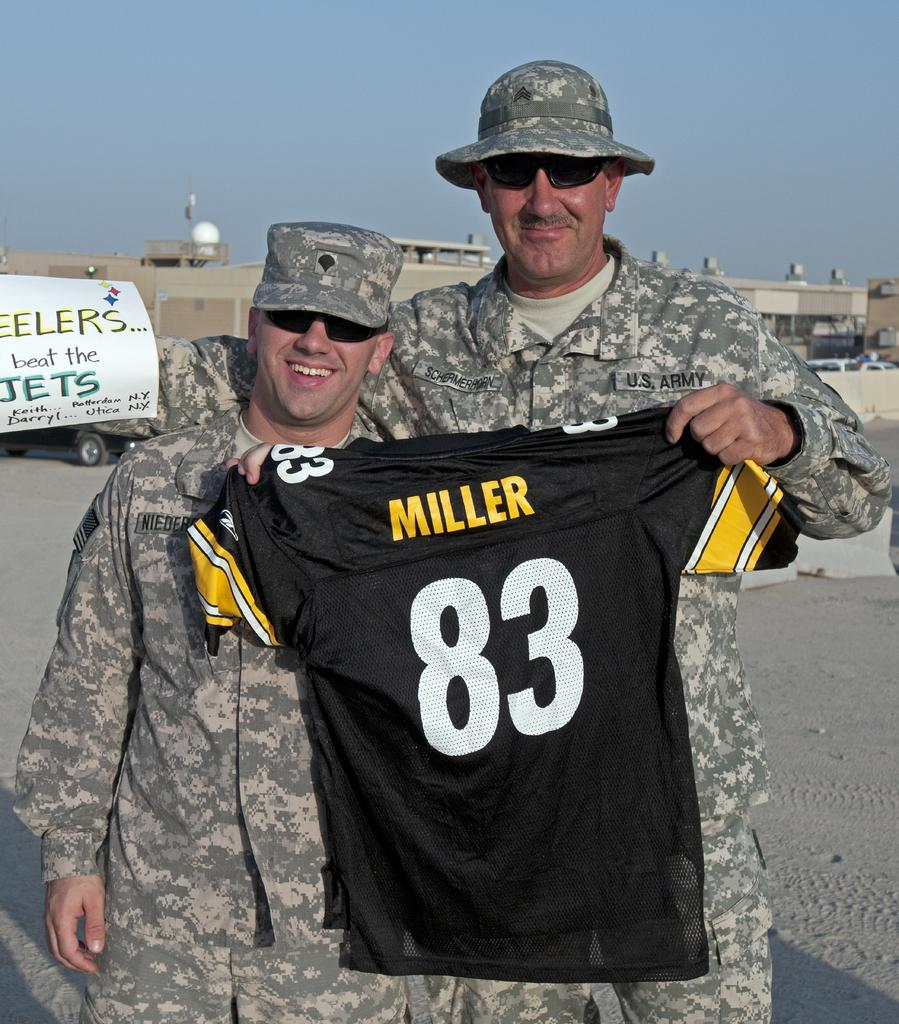<image>
Write a terse but informative summary of the picture. two men from the U.S. army holding up a number 83 miller jersey 